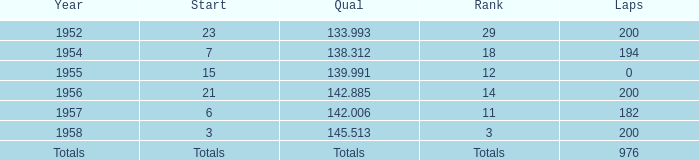What place did Jimmy Reece start from when he ranked 12? 15.0. 